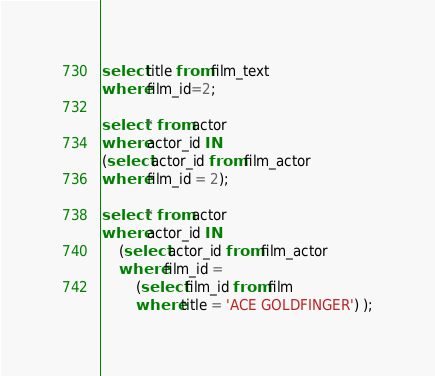<code> <loc_0><loc_0><loc_500><loc_500><_SQL_>select title from film_text
where film_id=2;

select * from actor
where actor_id IN
(select actor_id from film_actor
where film_id = 2);

select * from actor
where actor_id IN
	(select actor_id from film_actor
	where film_id = 
		(select film_id from film
		where title = 'ACE GOLDFINGER') );</code> 